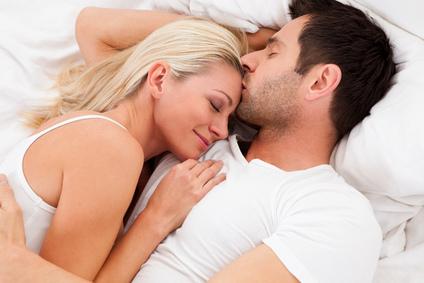Is she a blonde?
Quick response, please. Yes. Are these people sleeping?
Write a very short answer. Yes. What color are they wearing?
Write a very short answer. White. Is this an ad for Viagra?
Answer briefly. No. 